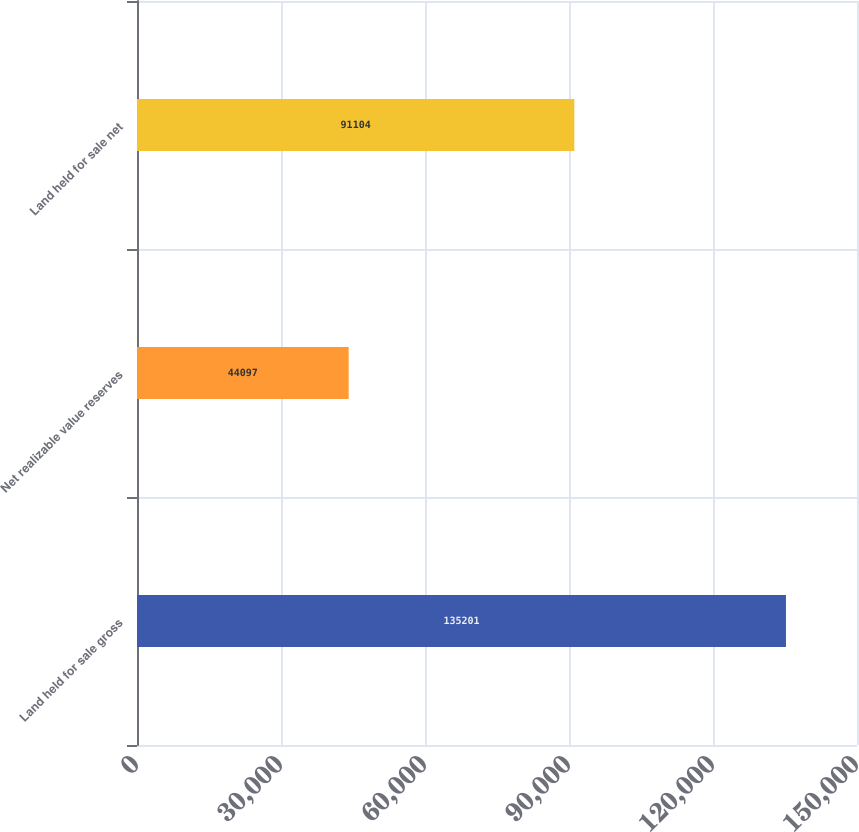Convert chart. <chart><loc_0><loc_0><loc_500><loc_500><bar_chart><fcel>Land held for sale gross<fcel>Net realizable value reserves<fcel>Land held for sale net<nl><fcel>135201<fcel>44097<fcel>91104<nl></chart> 